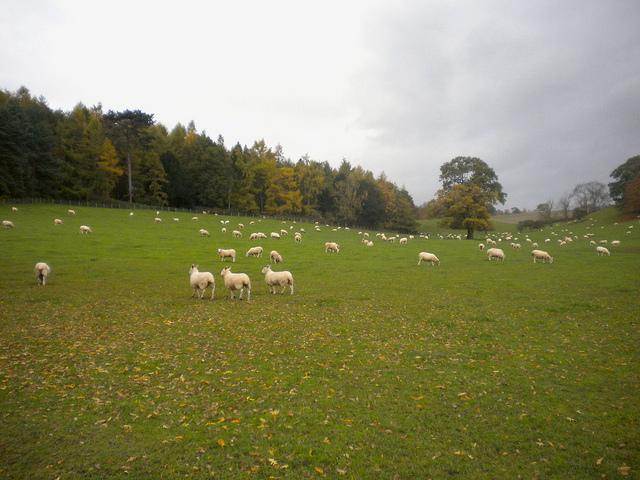Is there a shepherd among the sheep?
Write a very short answer. No. Is this photo taken in the city?
Answer briefly. No. Are this sheep?
Be succinct. Yes. 